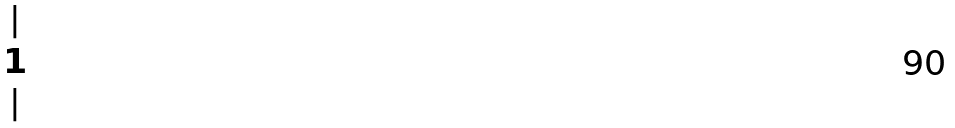Convert formula to latex. <formula><loc_0><loc_0><loc_500><loc_500>\begin{matrix} | \\ 1 \\ | \end{matrix}</formula> 